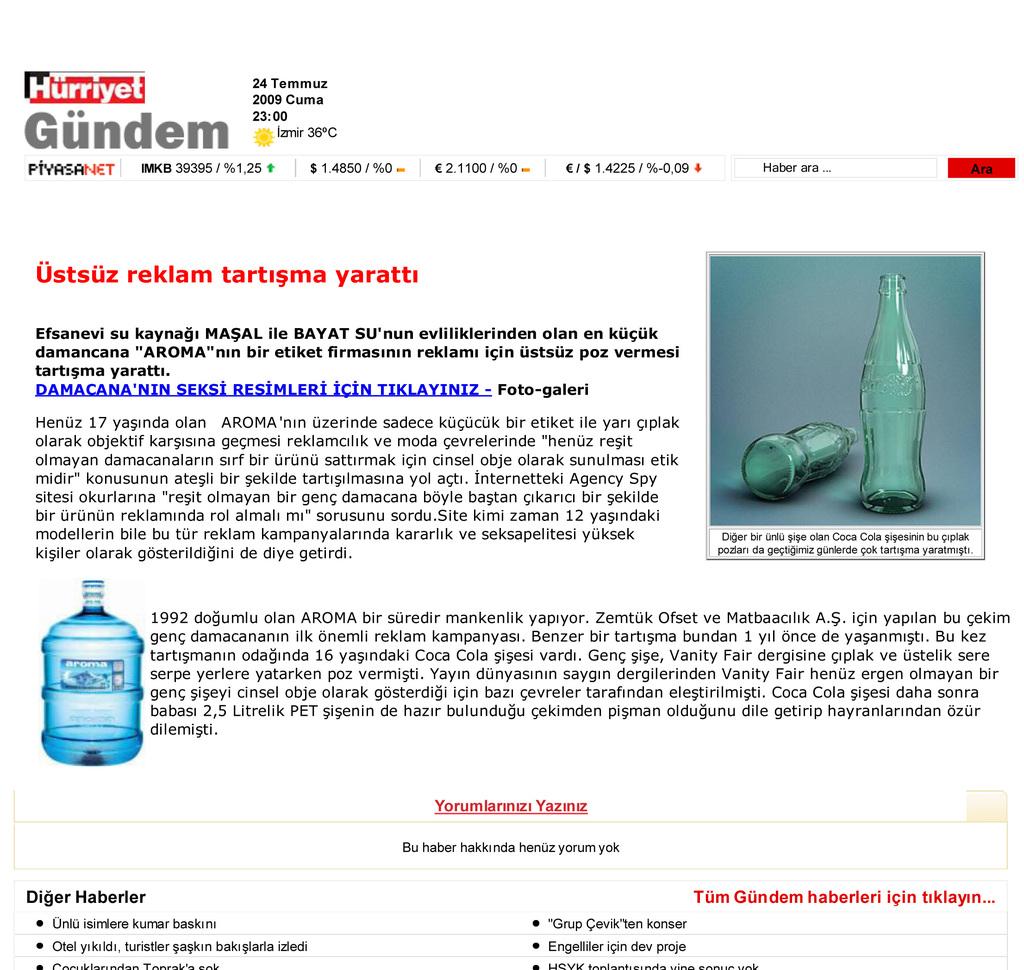Who put out this article?
Provide a succinct answer. Gundem. 